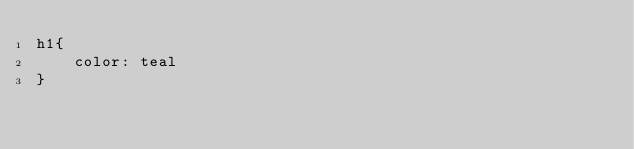<code> <loc_0><loc_0><loc_500><loc_500><_CSS_>h1{
    color: teal
}
</code> 